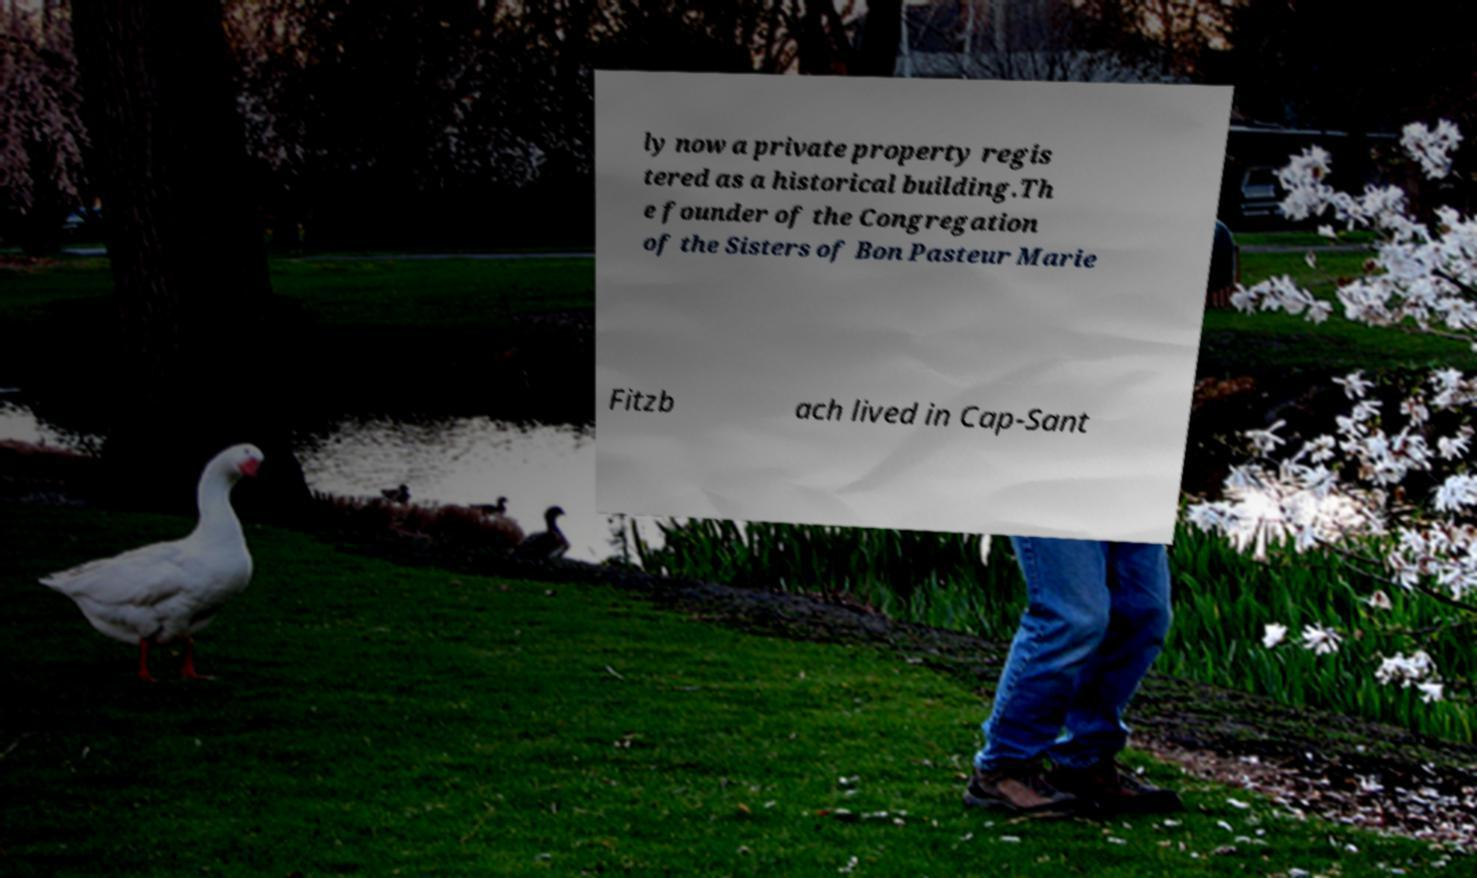Please read and relay the text visible in this image. What does it say? ly now a private property regis tered as a historical building.Th e founder of the Congregation of the Sisters of Bon Pasteur Marie Fitzb ach lived in Cap-Sant 